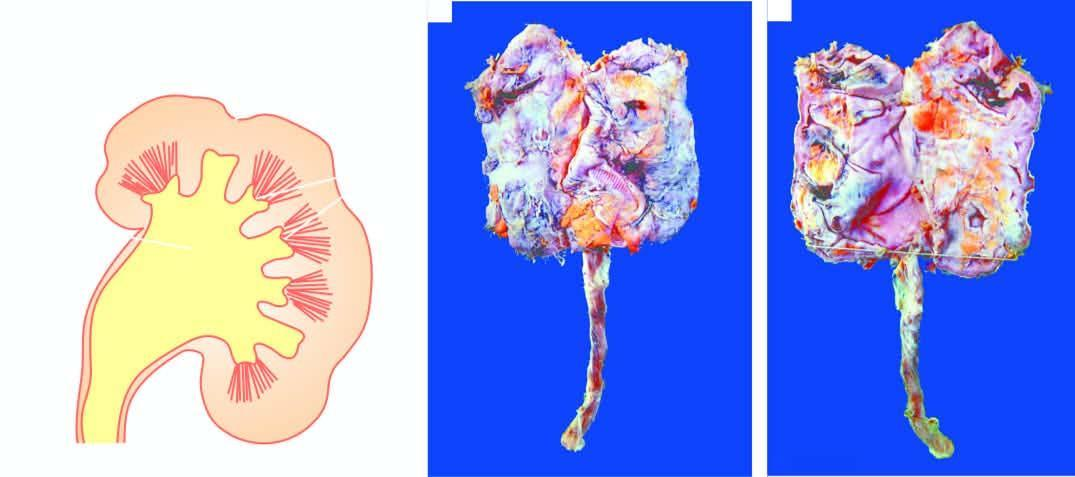s small contracted kidney in chronic pyelonephritis with calyectasis?
Answer the question using a single word or phrase. Yes 